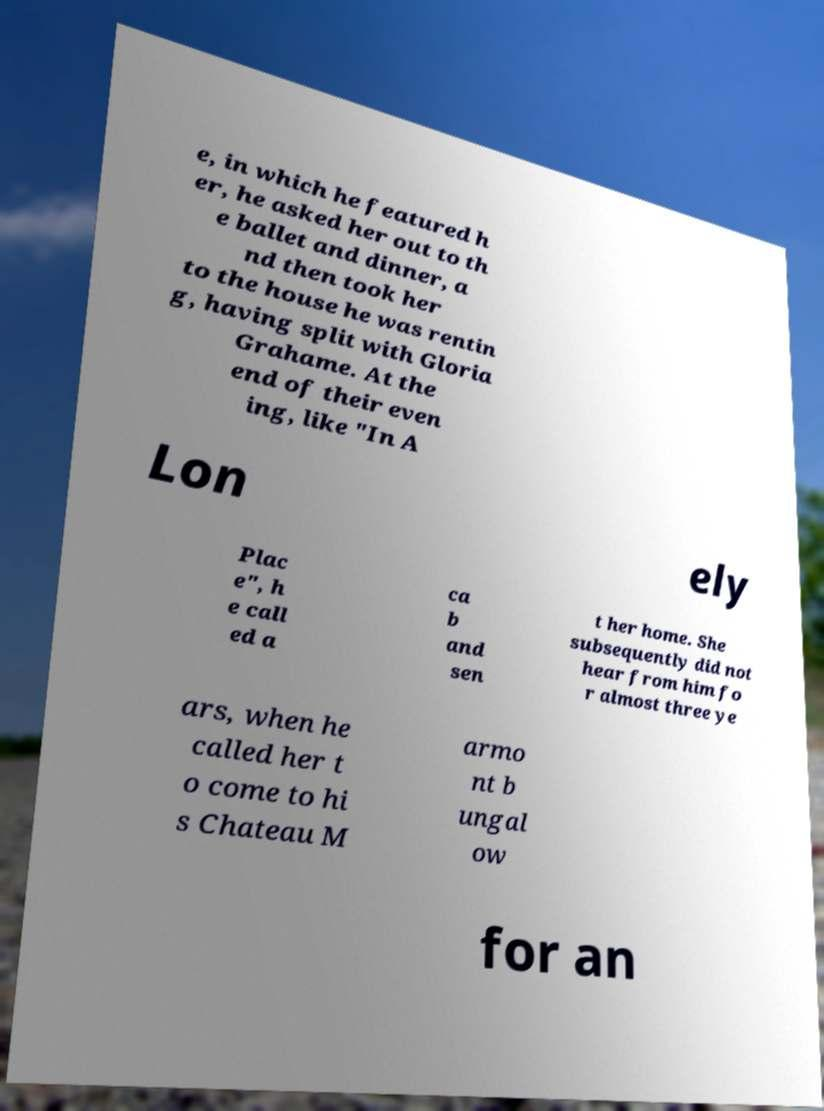Can you read and provide the text displayed in the image?This photo seems to have some interesting text. Can you extract and type it out for me? e, in which he featured h er, he asked her out to th e ballet and dinner, a nd then took her to the house he was rentin g, having split with Gloria Grahame. At the end of their even ing, like "In A Lon ely Plac e", h e call ed a ca b and sen t her home. She subsequently did not hear from him fo r almost three ye ars, when he called her t o come to hi s Chateau M armo nt b ungal ow for an 